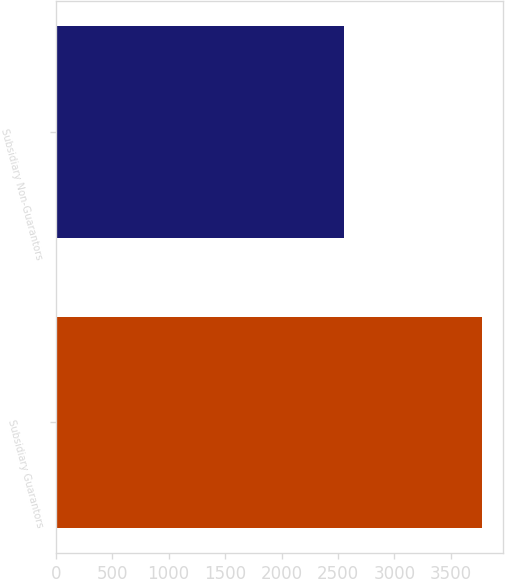<chart> <loc_0><loc_0><loc_500><loc_500><bar_chart><fcel>Subsidiary Guarantors<fcel>Subsidiary Non-Guarantors<nl><fcel>3772<fcel>2550<nl></chart> 